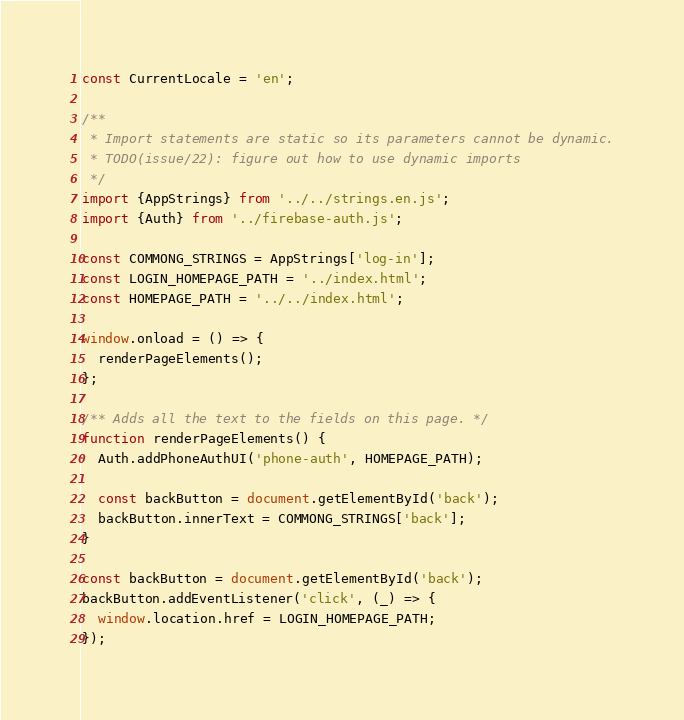<code> <loc_0><loc_0><loc_500><loc_500><_JavaScript_>const CurrentLocale = 'en';

/**
 * Import statements are static so its parameters cannot be dynamic.
 * TODO(issue/22): figure out how to use dynamic imports
 */
import {AppStrings} from '../../strings.en.js';
import {Auth} from '../firebase-auth.js';

const COMMONG_STRINGS = AppStrings['log-in'];
const LOGIN_HOMEPAGE_PATH = '../index.html';
const HOMEPAGE_PATH = '../../index.html';

window.onload = () => {
  renderPageElements();
};

/** Adds all the text to the fields on this page. */
function renderPageElements() {
  Auth.addPhoneAuthUI('phone-auth', HOMEPAGE_PATH);

  const backButton = document.getElementById('back');
  backButton.innerText = COMMONG_STRINGS['back'];
}

const backButton = document.getElementById('back');
backButton.addEventListener('click', (_) => {
  window.location.href = LOGIN_HOMEPAGE_PATH;
});
</code> 